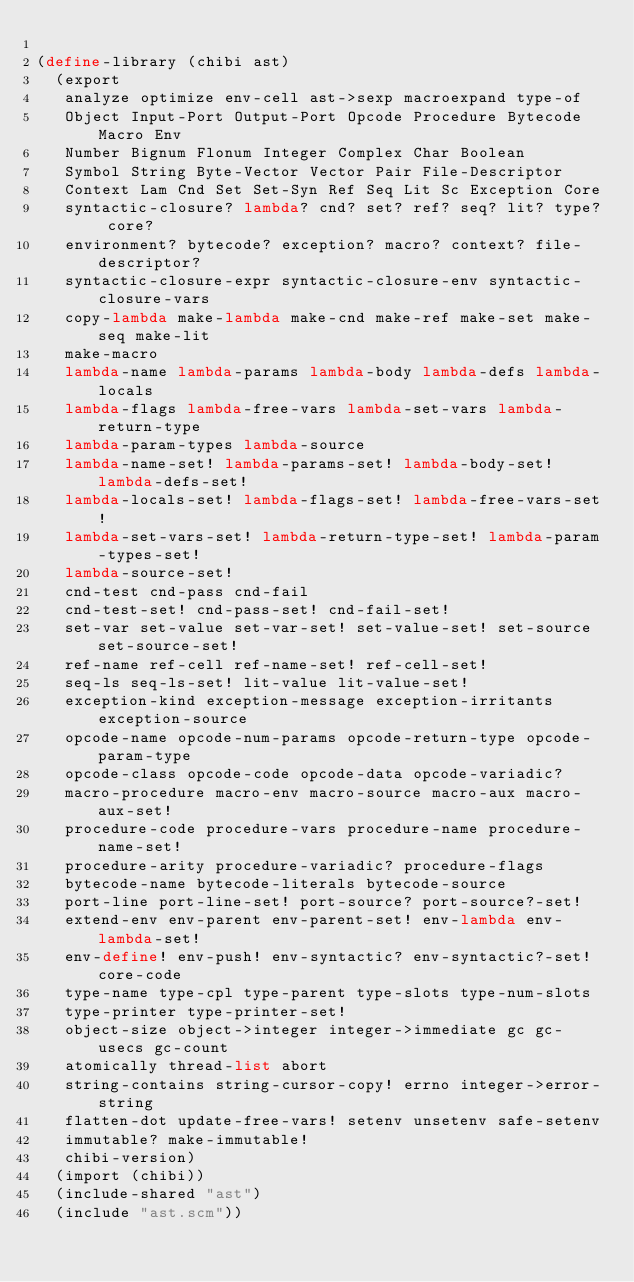Convert code to text. <code><loc_0><loc_0><loc_500><loc_500><_Scheme_>
(define-library (chibi ast)
  (export
   analyze optimize env-cell ast->sexp macroexpand type-of
   Object Input-Port Output-Port Opcode Procedure Bytecode Macro Env
   Number Bignum Flonum Integer Complex Char Boolean
   Symbol String Byte-Vector Vector Pair File-Descriptor
   Context Lam Cnd Set Set-Syn Ref Seq Lit Sc Exception Core
   syntactic-closure? lambda? cnd? set? ref? seq? lit? type? core?
   environment? bytecode? exception? macro? context? file-descriptor?
   syntactic-closure-expr syntactic-closure-env syntactic-closure-vars
   copy-lambda make-lambda make-cnd make-ref make-set make-seq make-lit
   make-macro
   lambda-name lambda-params lambda-body lambda-defs lambda-locals
   lambda-flags lambda-free-vars lambda-set-vars lambda-return-type
   lambda-param-types lambda-source
   lambda-name-set! lambda-params-set! lambda-body-set! lambda-defs-set!
   lambda-locals-set! lambda-flags-set! lambda-free-vars-set!
   lambda-set-vars-set! lambda-return-type-set! lambda-param-types-set!
   lambda-source-set!
   cnd-test cnd-pass cnd-fail
   cnd-test-set! cnd-pass-set! cnd-fail-set!
   set-var set-value set-var-set! set-value-set! set-source set-source-set!
   ref-name ref-cell ref-name-set! ref-cell-set!
   seq-ls seq-ls-set! lit-value lit-value-set!
   exception-kind exception-message exception-irritants exception-source
   opcode-name opcode-num-params opcode-return-type opcode-param-type
   opcode-class opcode-code opcode-data opcode-variadic?
   macro-procedure macro-env macro-source macro-aux macro-aux-set!
   procedure-code procedure-vars procedure-name procedure-name-set!
   procedure-arity procedure-variadic? procedure-flags
   bytecode-name bytecode-literals bytecode-source
   port-line port-line-set! port-source? port-source?-set!
   extend-env env-parent env-parent-set! env-lambda env-lambda-set!
   env-define! env-push! env-syntactic? env-syntactic?-set! core-code
   type-name type-cpl type-parent type-slots type-num-slots
   type-printer type-printer-set!
   object-size object->integer integer->immediate gc gc-usecs gc-count
   atomically thread-list abort
   string-contains string-cursor-copy! errno integer->error-string
   flatten-dot update-free-vars! setenv unsetenv safe-setenv
   immutable? make-immutable!
   chibi-version)
  (import (chibi))
  (include-shared "ast")
  (include "ast.scm"))
</code> 